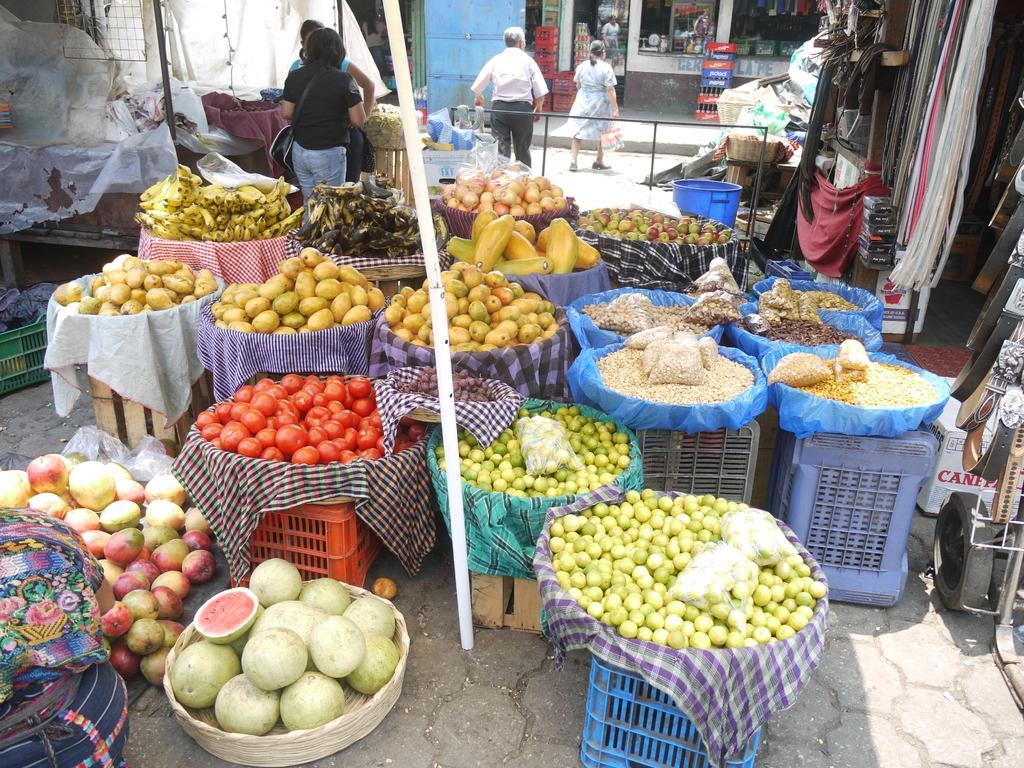In one or two sentences, can you explain what this image depicts? In the middle of this image, there are tomatoes, bananas, lemons and other food items arranged in the baskets which are placed on the surface of the baskets and there is a white color pole. On the left side, there are fruits and a person. On the right side, there are belts. In the background, there are other persons, baskets arranged, a building which is having glass windows and there are other objects. 